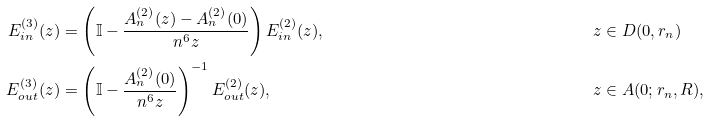Convert formula to latex. <formula><loc_0><loc_0><loc_500><loc_500>E _ { i n } ^ { ( 3 ) } ( z ) & = \left ( \mathbb { I } - \frac { A _ { n } ^ { ( 2 ) } ( z ) - A _ { n } ^ { ( 2 ) } ( 0 ) } { n ^ { 6 } z } \right ) E _ { i n } ^ { ( 2 ) } ( z ) , & & z \in D ( 0 , r _ { n } ) \\ E _ { o u t } ^ { ( 3 ) } ( z ) & = \left ( \mathbb { I } - \frac { A _ { n } ^ { ( 2 ) } ( 0 ) } { n ^ { 6 } z } \right ) ^ { - 1 } E _ { o u t } ^ { ( 2 ) } ( z ) , & & z \in A ( 0 ; r _ { n } , R ) ,</formula> 